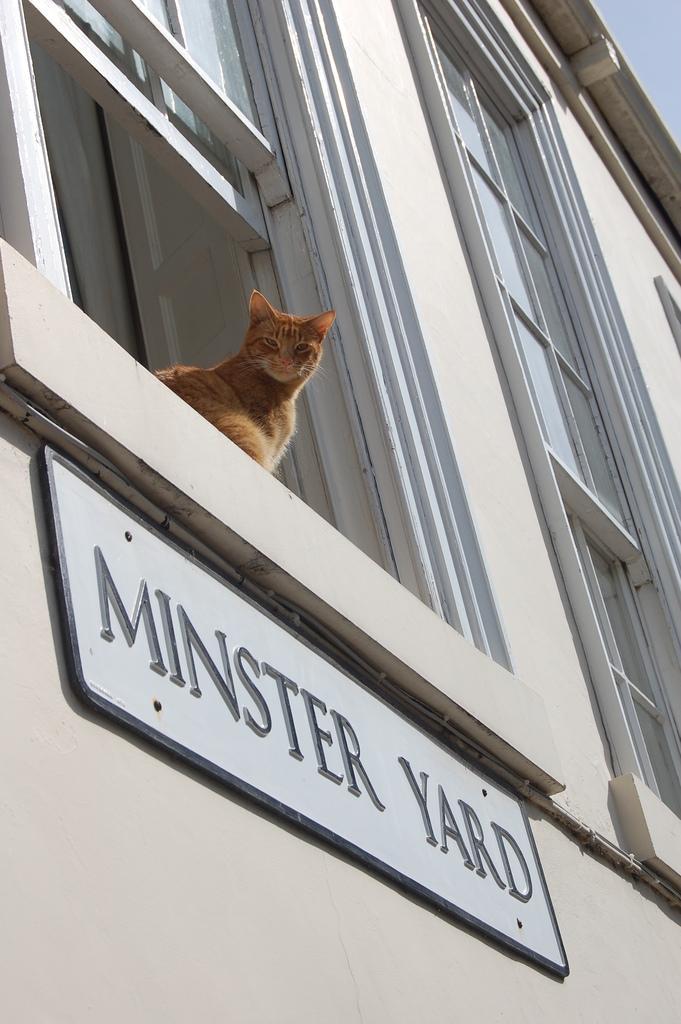Could you give a brief overview of what you see in this image? This is a cat sitting near the window. I can see a name board, which is attached to the wall. These are the windows with doors. 